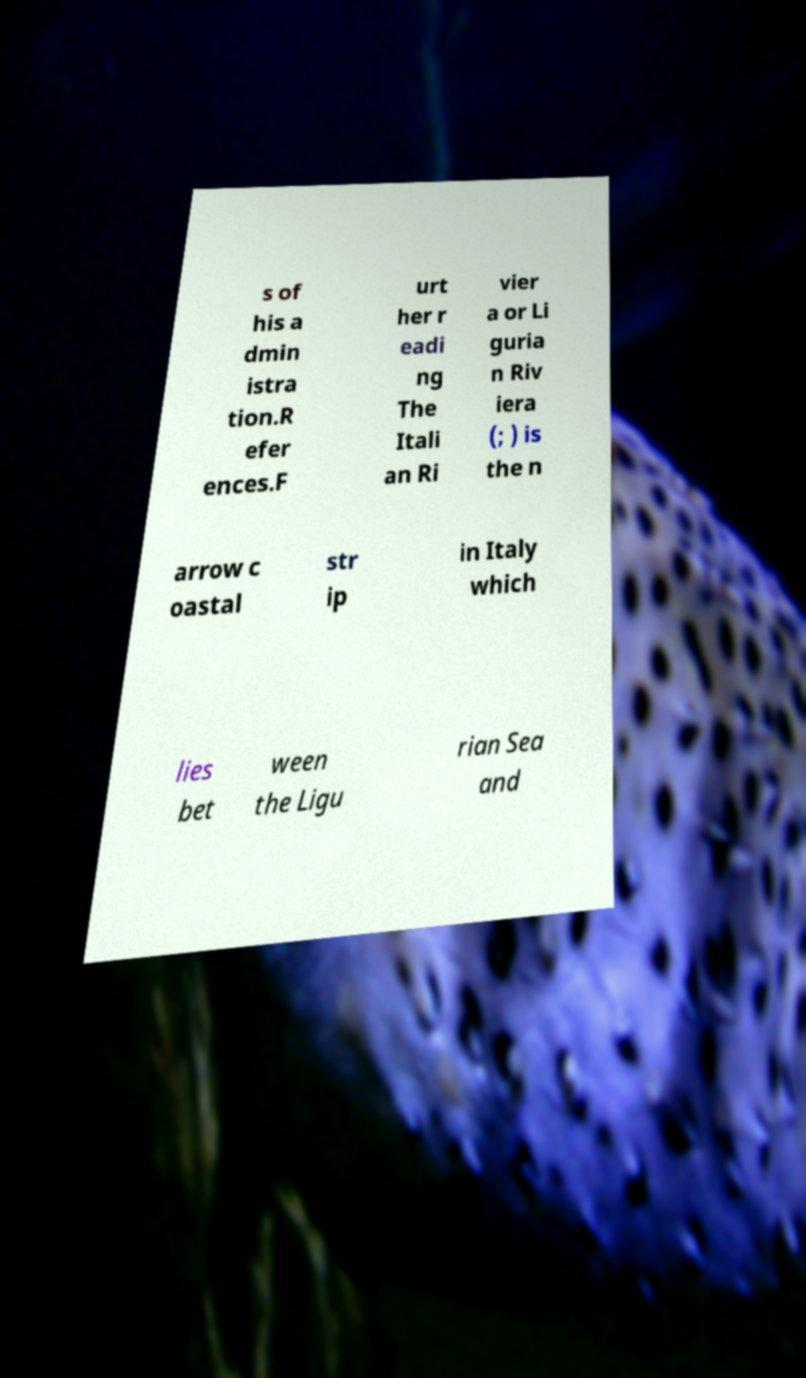There's text embedded in this image that I need extracted. Can you transcribe it verbatim? s of his a dmin istra tion.R efer ences.F urt her r eadi ng The Itali an Ri vier a or Li guria n Riv iera (; ) is the n arrow c oastal str ip in Italy which lies bet ween the Ligu rian Sea and 